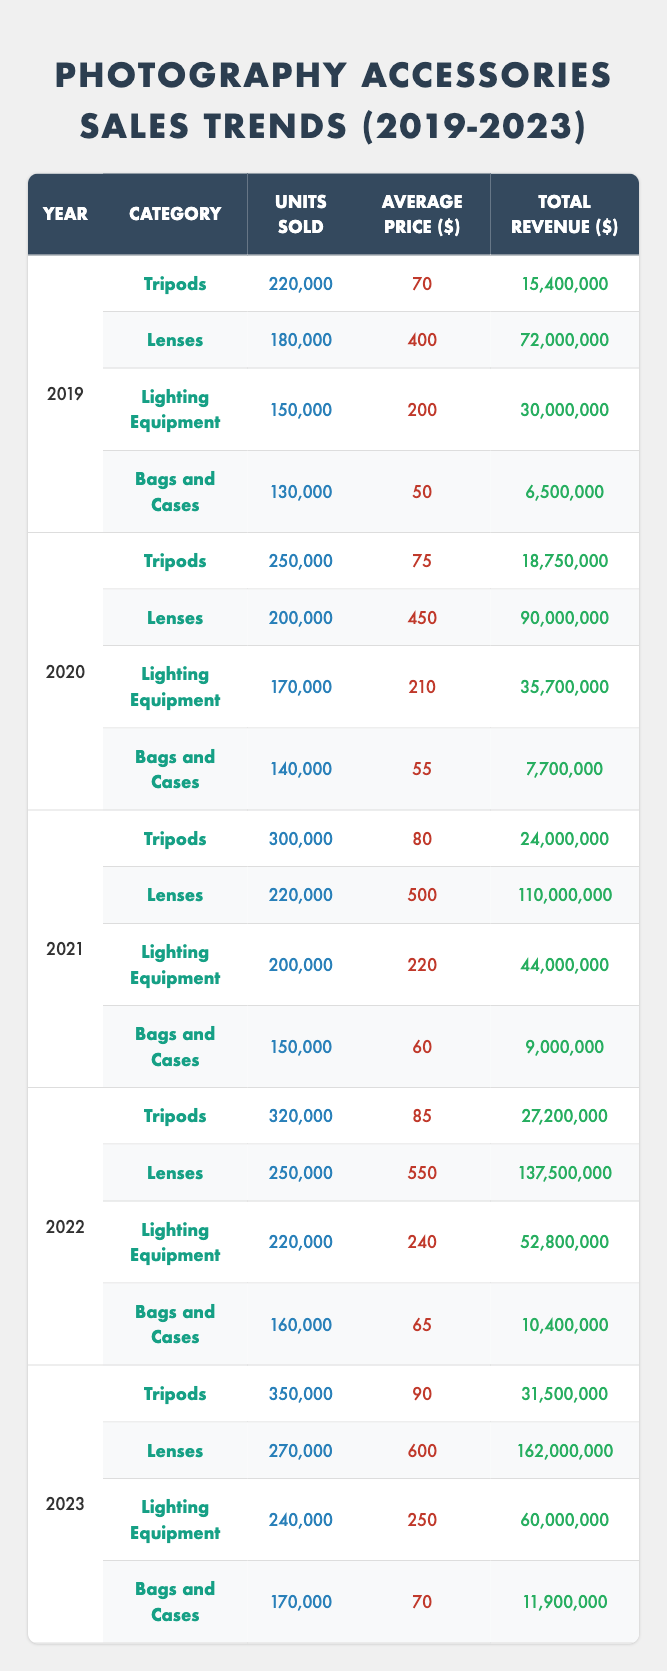What was the total revenue from lenses in 2021? The total revenue from lenses in 2021 is provided directly in the table. It states that the total revenue for lenses sold that year was 110,000,000.
Answer: 110,000,000 How many tripods were sold in 2022 compared to 2019? In 2022, 320,000 tripods were sold, while in 2019, 220,000 tripods were sold. To find the difference, we subtract 220,000 from 320,000, which equals 100,000.
Answer: 100,000 What was the average price of lighting equipment over the five years? To find the average price, we first sum the average prices: 200 + 210 + 220 + 240 + 250 = 1130. Then, we divide by 5 (the number of years), which gives us an average price of 226.
Answer: 226 Did the sales of bags and cases increase every year from 2019 to 2023? By examining the units sold each year, we see the following: 130,000 (2019), 140,000 (2020), 150,000 (2021), 160,000 (2022), and 170,000 (2023). Since the units sold increased every year, the answer is yes.
Answer: Yes In which year was the total revenue of tripods the highest? The total revenue for tripods over the years is as follows: 15,400,000 (2019), 18,750,000 (2020), 24,000,000 (2021), 27,200,000 (2022), and 31,500,000 (2023). The highest revenue is in 2023 with 31,500,000.
Answer: 2023 What is the relationship between the units sold and total revenue for lenses in 2023? In 2023, the units sold for lenses were 270,000, and the average price was 600. Thus, the total revenue can be confirmed as 270,000 * 600 = 162,000,000, which confirms the values in the table. This calculation shows a direct relationship where higher units sold at an increased price lead to higher total revenue.
Answer: Direct relationship, confirmed by calculations Which accessory had the lowest total revenue in 2020? The total revenues for each accessory in 2020 are as follows: Tripods - 18,750,000, Lenses - 90,000,000, Lighting Equipment - 35,700,000, and Bags and Cases - 7,700,000. In 2020, bags and cases had the lowest total revenue at 7,700,000.
Answer: Bags and Cases What was the percentage increase in units sold for tripods from 2020 to 2023? The units sold for tripods in 2020 were 250,000 and in 2023 were 350,000. To calculate the percentage increase, we use the formula: ((New - Old) / Old) * 100 = ((350,000 - 250,000) / 250,000) * 100 = 40%.
Answer: 40% Was the average price of lenses lower in 2020 than in 2021? In 2020, the average price of lenses was 450, while in 2021 it was 500. Since 450 is less than 500, the statement is true.
Answer: Yes 